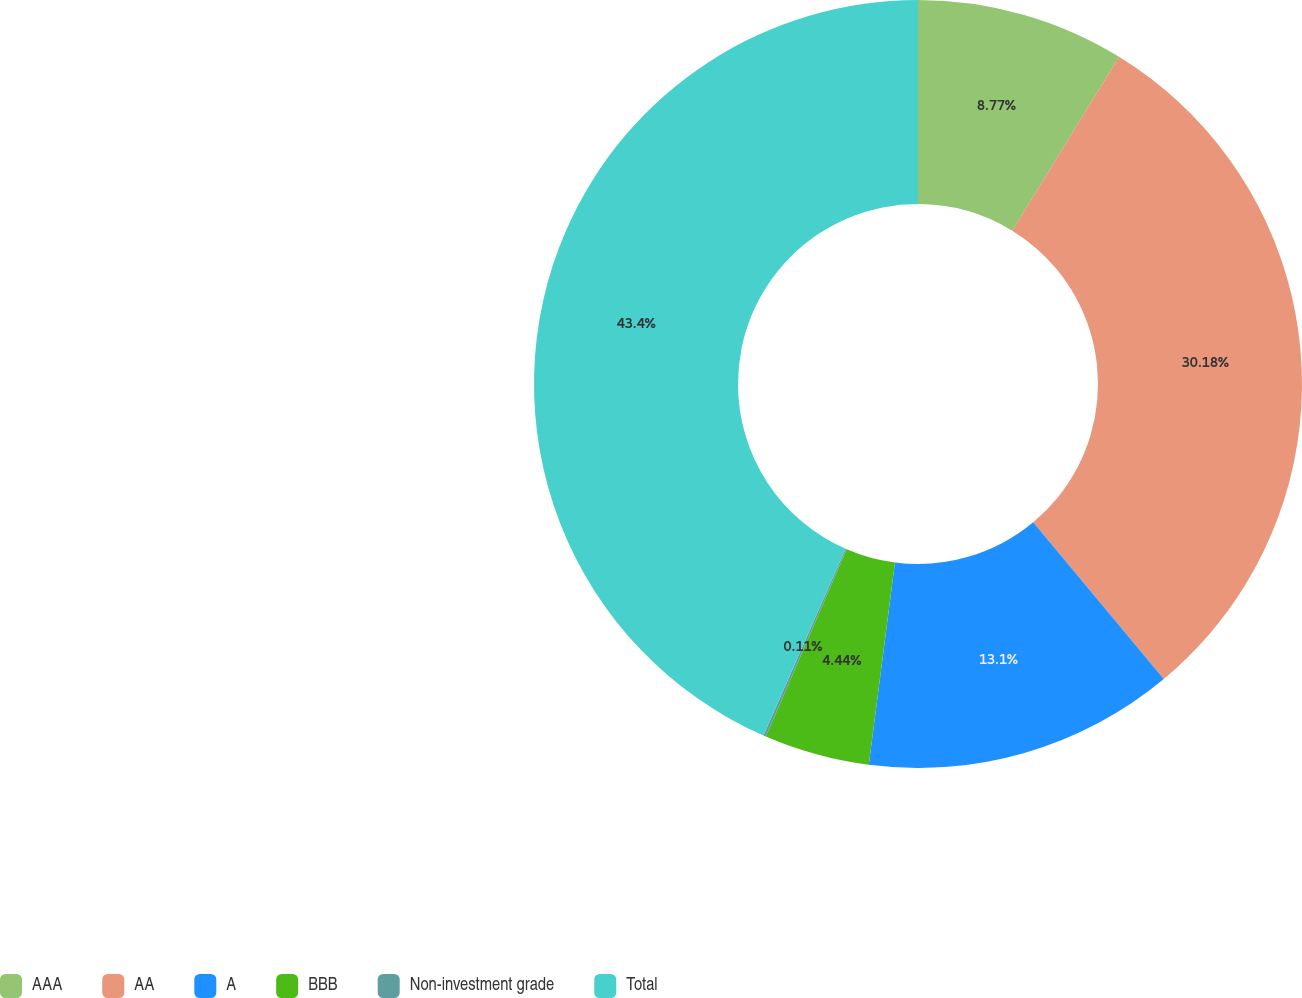Convert chart to OTSL. <chart><loc_0><loc_0><loc_500><loc_500><pie_chart><fcel>AAA<fcel>AA<fcel>A<fcel>BBB<fcel>Non-investment grade<fcel>Total<nl><fcel>8.77%<fcel>30.18%<fcel>13.1%<fcel>4.44%<fcel>0.11%<fcel>43.41%<nl></chart> 